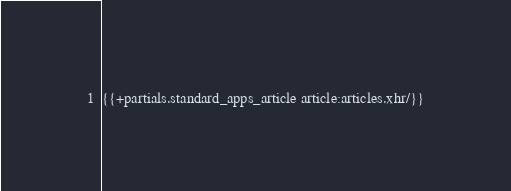Convert code to text. <code><loc_0><loc_0><loc_500><loc_500><_HTML_>{{+partials.standard_apps_article article:articles.xhr/}}
</code> 